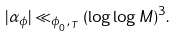Convert formula to latex. <formula><loc_0><loc_0><loc_500><loc_500>| \alpha _ { \phi } | \ll _ { \phi _ { _ { 0 } } , _ { T } } ( \log \log M ) ^ { 3 } .</formula> 